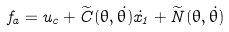Convert formula to latex. <formula><loc_0><loc_0><loc_500><loc_500>f _ { a } = u _ { c } + \widetilde { C } ( \theta , \dot { \theta } ) \dot { x } _ { 1 } + \widetilde { N } ( \theta , \dot { \theta } )</formula> 